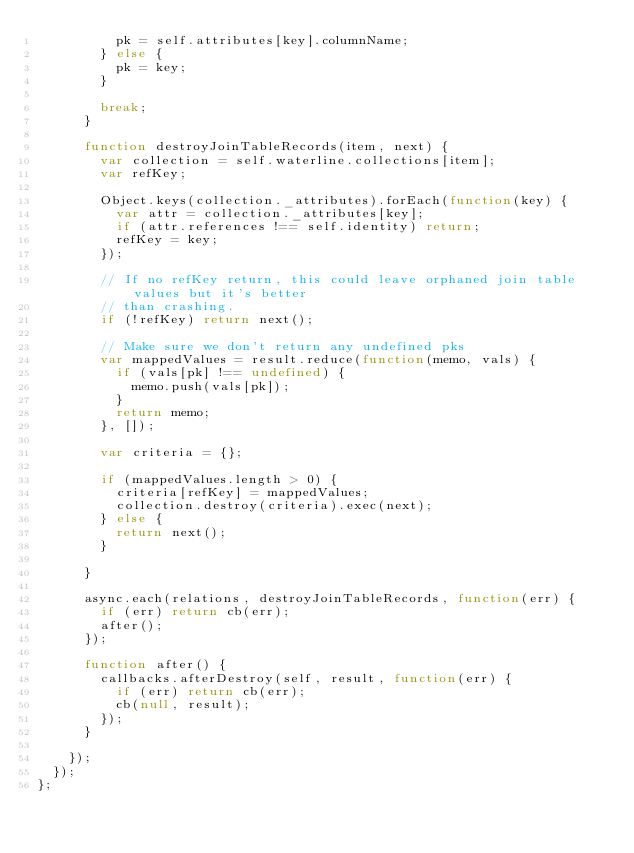<code> <loc_0><loc_0><loc_500><loc_500><_JavaScript_>          pk = self.attributes[key].columnName;
        } else {
          pk = key;
        }

        break;
      }

      function destroyJoinTableRecords(item, next) {
        var collection = self.waterline.collections[item];
        var refKey;

        Object.keys(collection._attributes).forEach(function(key) {
          var attr = collection._attributes[key];
          if (attr.references !== self.identity) return;
          refKey = key;
        });

        // If no refKey return, this could leave orphaned join table values but it's better
        // than crashing.
        if (!refKey) return next();

        // Make sure we don't return any undefined pks
        var mappedValues = result.reduce(function(memo, vals) {
          if (vals[pk] !== undefined) {
            memo.push(vals[pk]);
          }
          return memo;
        }, []);

        var criteria = {};

        if (mappedValues.length > 0) {
          criteria[refKey] = mappedValues;
          collection.destroy(criteria).exec(next);
        } else {
          return next();
        }

      }

      async.each(relations, destroyJoinTableRecords, function(err) {
        if (err) return cb(err);
        after();
      });

      function after() {
        callbacks.afterDestroy(self, result, function(err) {
          if (err) return cb(err);
          cb(null, result);
        });
      }

    });
  });
};
</code> 